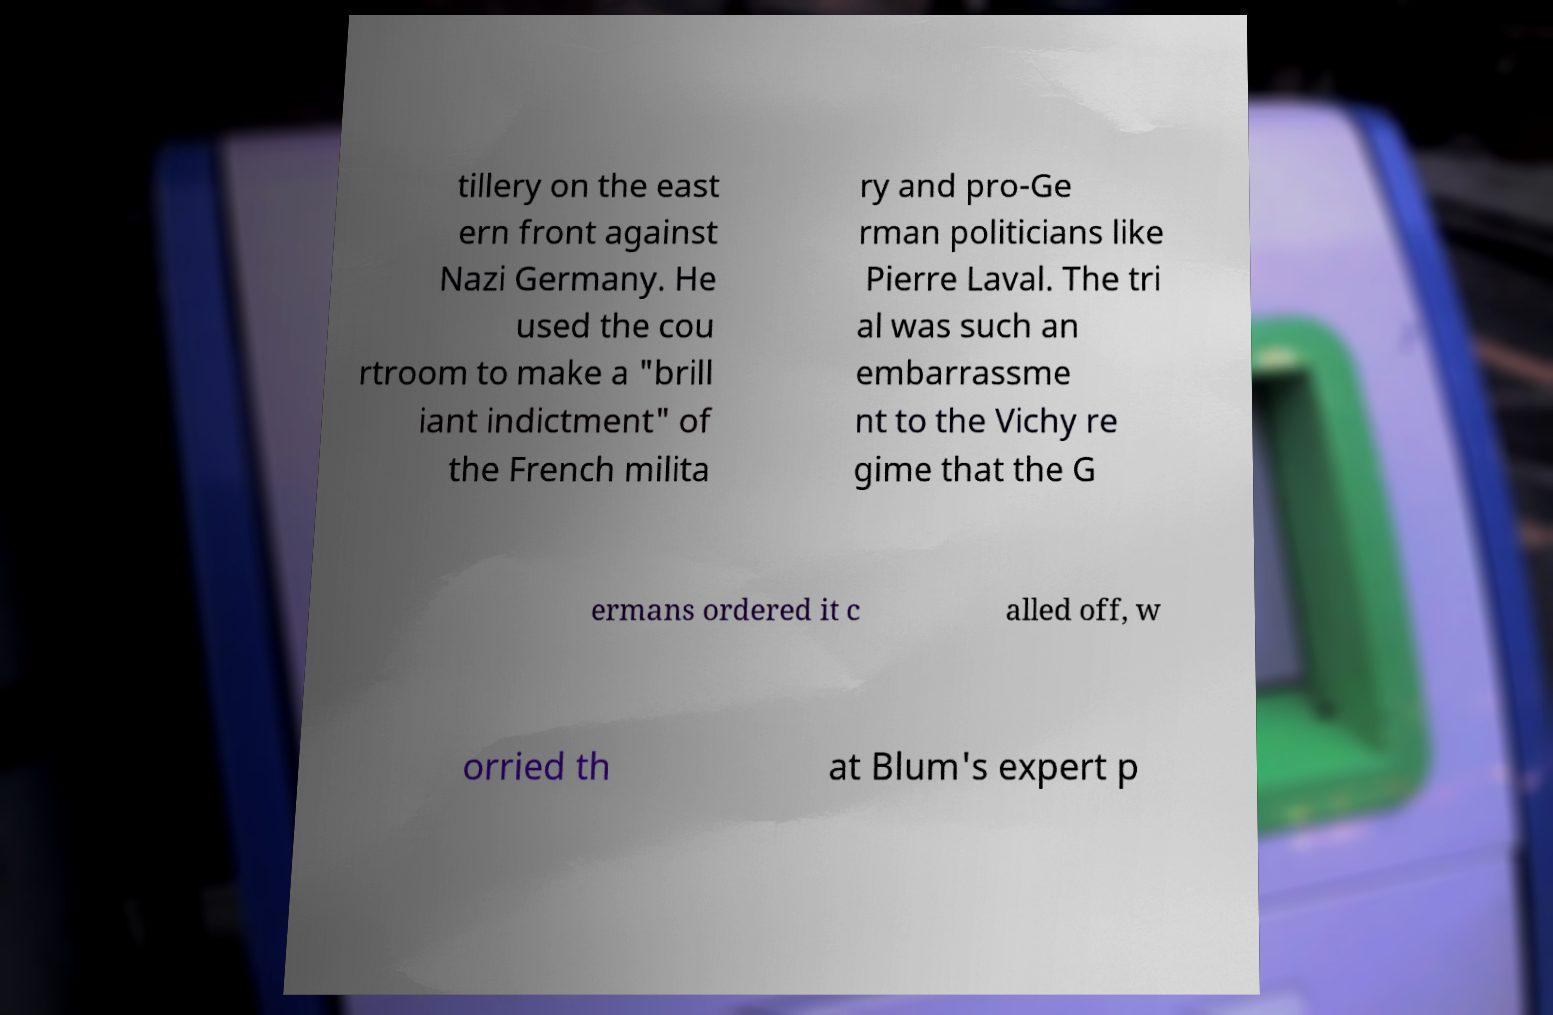Please read and relay the text visible in this image. What does it say? tillery on the east ern front against Nazi Germany. He used the cou rtroom to make a "brill iant indictment" of the French milita ry and pro-Ge rman politicians like Pierre Laval. The tri al was such an embarrassme nt to the Vichy re gime that the G ermans ordered it c alled off, w orried th at Blum's expert p 